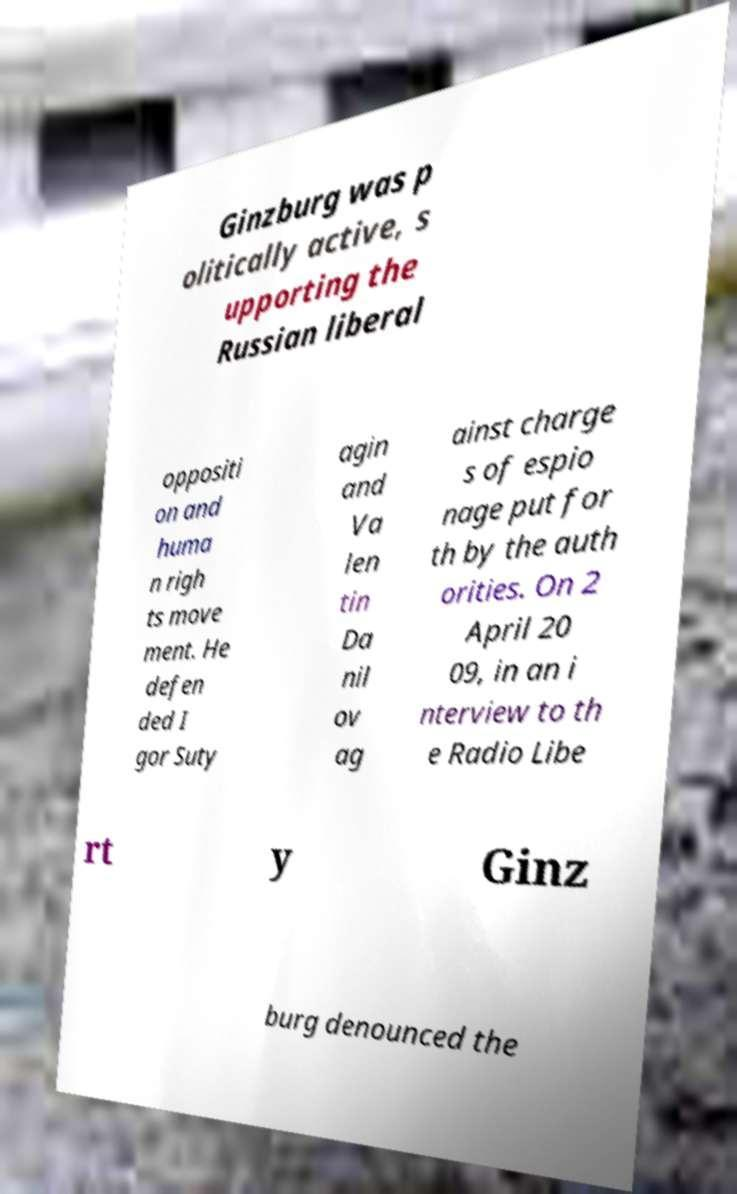There's text embedded in this image that I need extracted. Can you transcribe it verbatim? Ginzburg was p olitically active, s upporting the Russian liberal oppositi on and huma n righ ts move ment. He defen ded I gor Suty agin and Va len tin Da nil ov ag ainst charge s of espio nage put for th by the auth orities. On 2 April 20 09, in an i nterview to th e Radio Libe rt y Ginz burg denounced the 